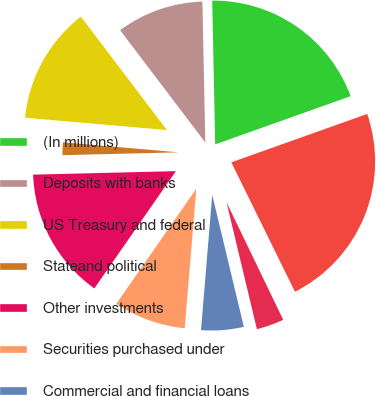Convert chart. <chart><loc_0><loc_0><loc_500><loc_500><pie_chart><fcel>(In millions)<fcel>Deposits with banks<fcel>US Treasury and federal<fcel>Stateand political<fcel>Other investments<fcel>Securities purchased under<fcel>Commercial and financial loans<fcel>Lease financing<fcel>Trading account assets<fcel>Total interest revenue<nl><fcel>19.88%<fcel>10.0%<fcel>13.29%<fcel>1.77%<fcel>14.94%<fcel>8.35%<fcel>5.06%<fcel>3.41%<fcel>0.12%<fcel>23.17%<nl></chart> 